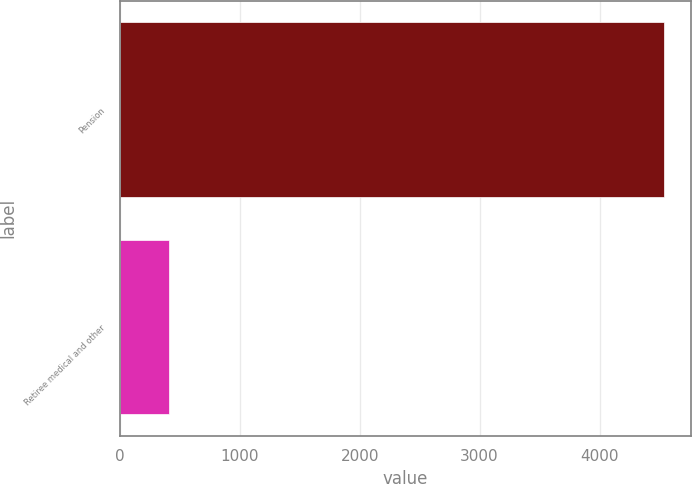<chart> <loc_0><loc_0><loc_500><loc_500><bar_chart><fcel>Pension<fcel>Retiree medical and other<nl><fcel>4535<fcel>414<nl></chart> 